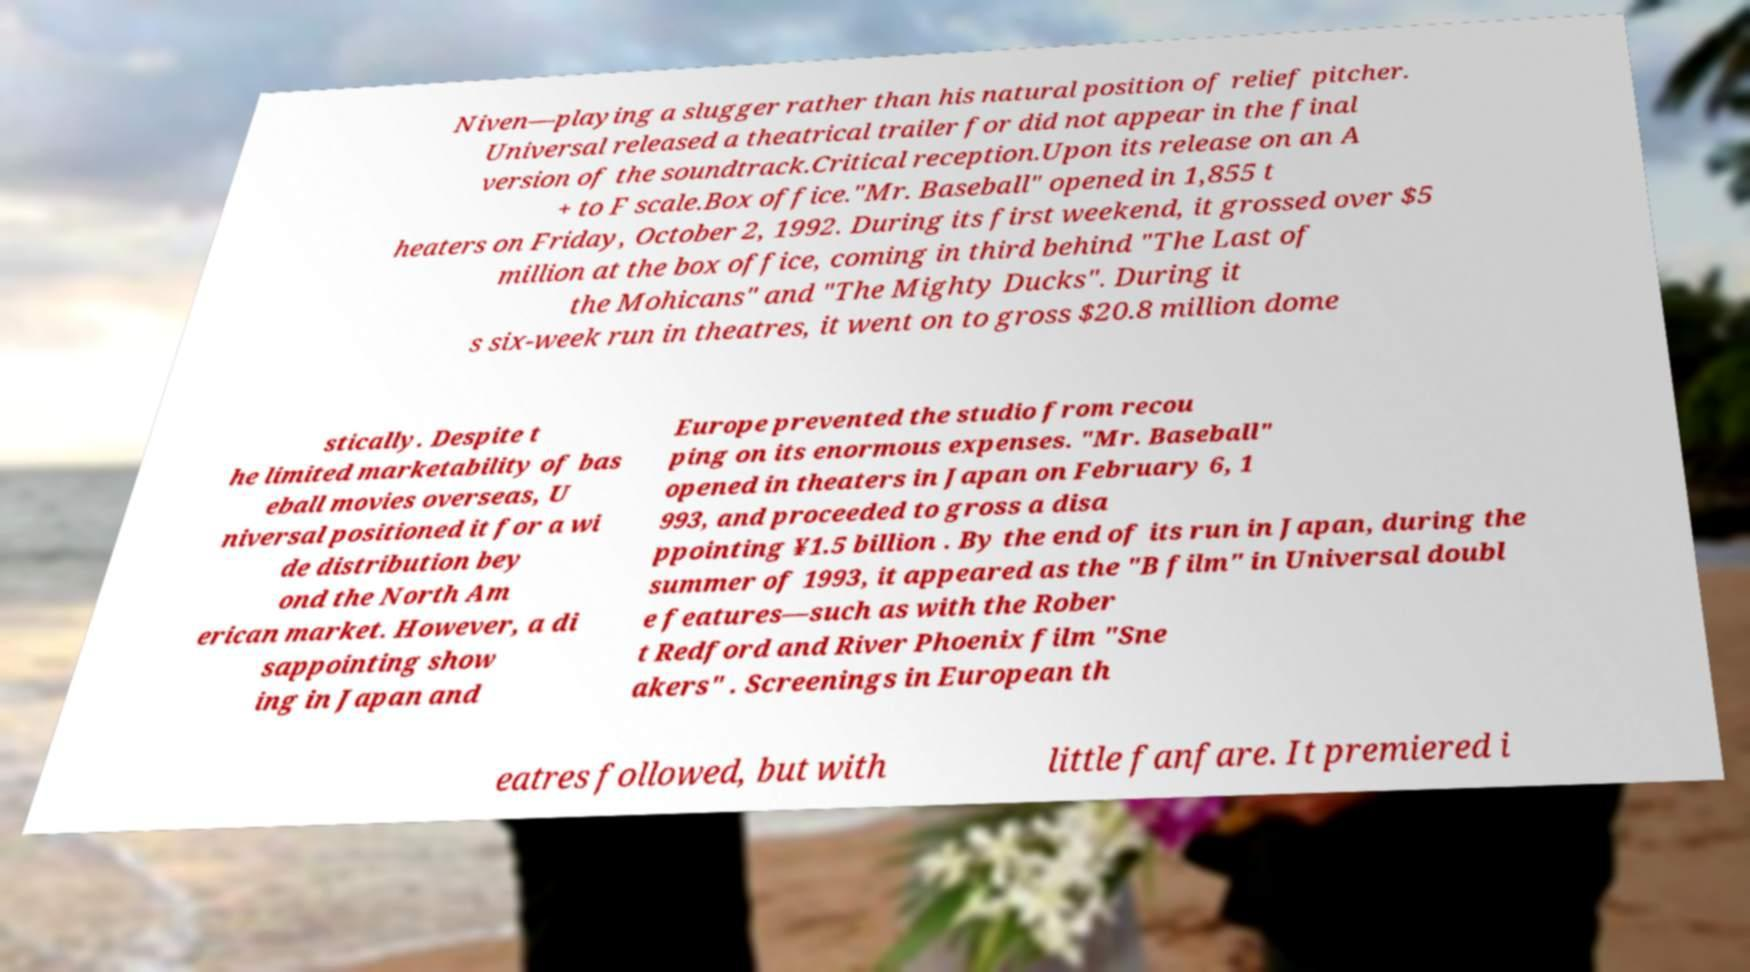Please read and relay the text visible in this image. What does it say? Niven—playing a slugger rather than his natural position of relief pitcher. Universal released a theatrical trailer for did not appear in the final version of the soundtrack.Critical reception.Upon its release on an A + to F scale.Box office."Mr. Baseball" opened in 1,855 t heaters on Friday, October 2, 1992. During its first weekend, it grossed over $5 million at the box office, coming in third behind "The Last of the Mohicans" and "The Mighty Ducks". During it s six-week run in theatres, it went on to gross $20.8 million dome stically. Despite t he limited marketability of bas eball movies overseas, U niversal positioned it for a wi de distribution bey ond the North Am erican market. However, a di sappointing show ing in Japan and Europe prevented the studio from recou ping on its enormous expenses. "Mr. Baseball" opened in theaters in Japan on February 6, 1 993, and proceeded to gross a disa ppointing ¥1.5 billion . By the end of its run in Japan, during the summer of 1993, it appeared as the "B film" in Universal doubl e features—such as with the Rober t Redford and River Phoenix film "Sne akers" . Screenings in European th eatres followed, but with little fanfare. It premiered i 